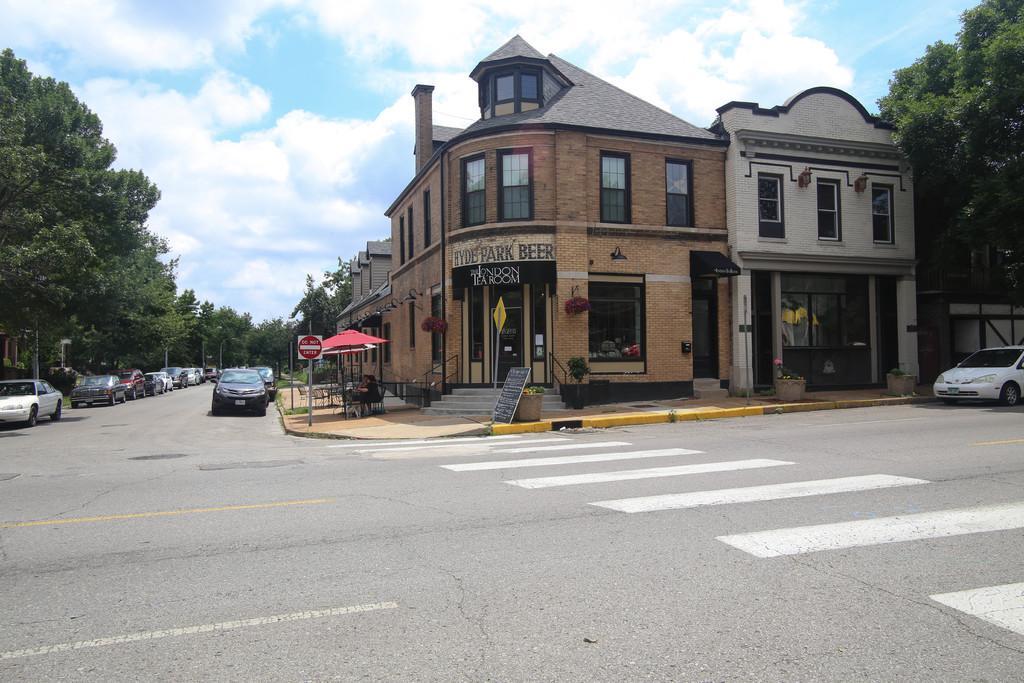Can you describe this image briefly? In this image at the center there is a building. In front of the building there is a tent. Under the tent people were sitting on the chairs. At the left side of the image there are cars on the road. On both right and left side of the image there are trees. There is a signal board beside the road. At the background there is sky. 